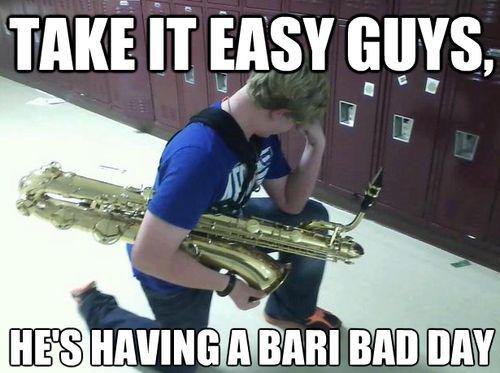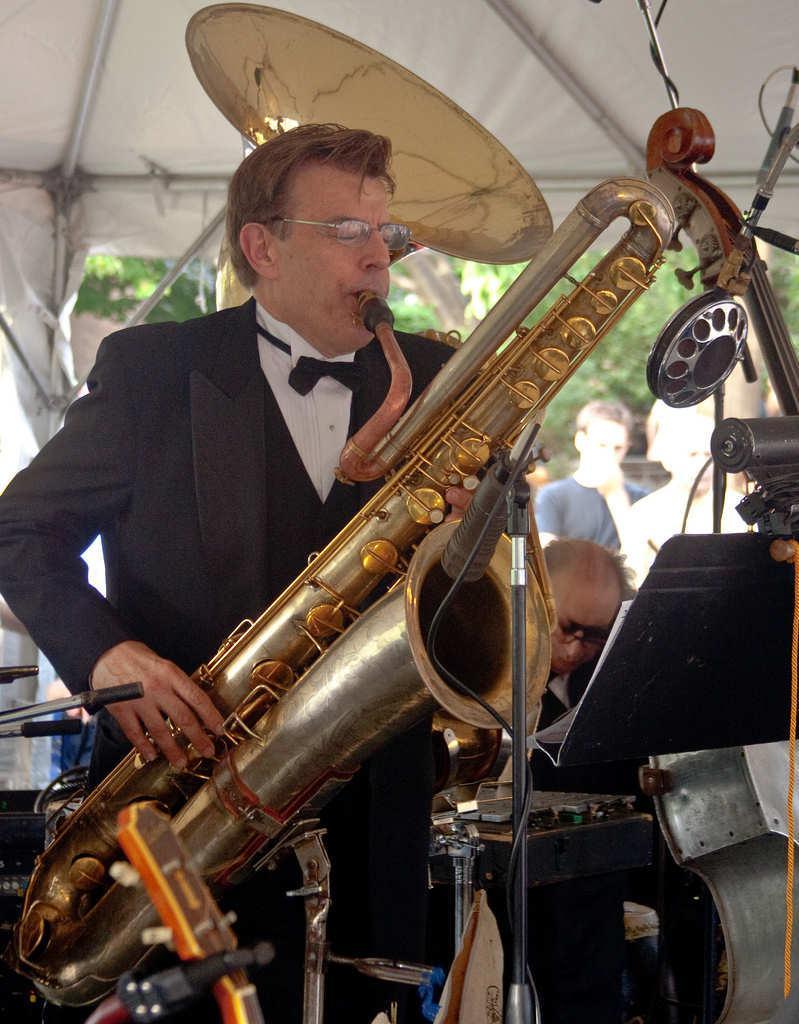The first image is the image on the left, the second image is the image on the right. Analyze the images presented: Is the assertion "Two people are playing instruments." valid? Answer yes or no. No. The first image is the image on the left, the second image is the image on the right. Analyze the images presented: Is the assertion "One man is standing and blowing into the mouthpiece of a brass instrument positioned diagonally to the right." valid? Answer yes or no. Yes. 